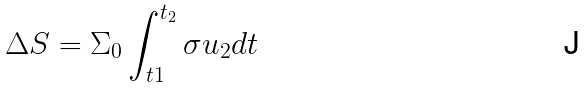<formula> <loc_0><loc_0><loc_500><loc_500>\Delta S = \Sigma _ { 0 } \int _ { t 1 } ^ { t _ { 2 } } \sigma u _ { 2 } d t</formula> 